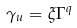Convert formula to latex. <formula><loc_0><loc_0><loc_500><loc_500>\gamma _ { u } = \xi \Gamma ^ { q }</formula> 